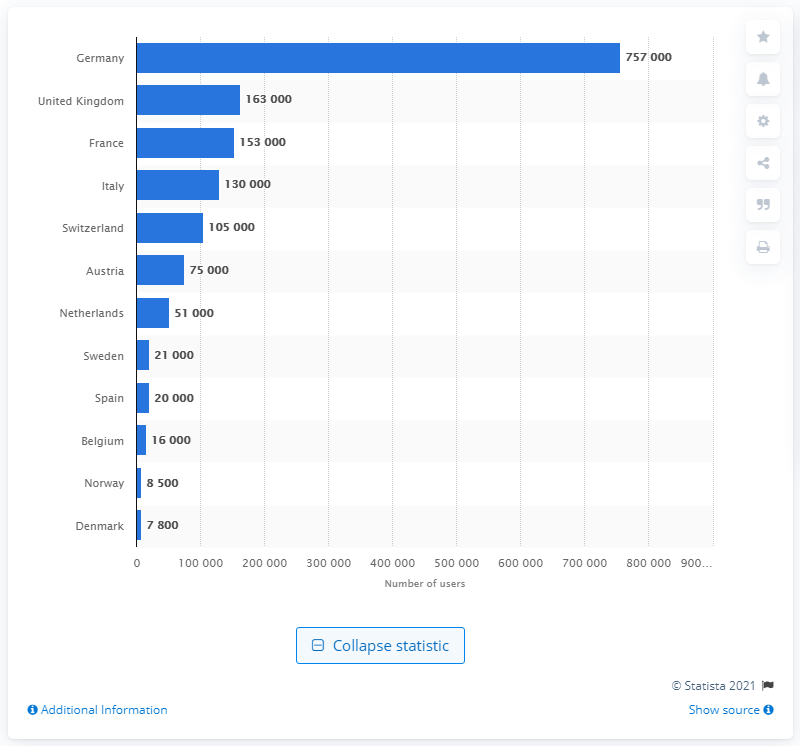Mention a couple of crucial points in this snapshot. According to a recent study, Germany had the highest number of people using car sharing companies in Europe. 